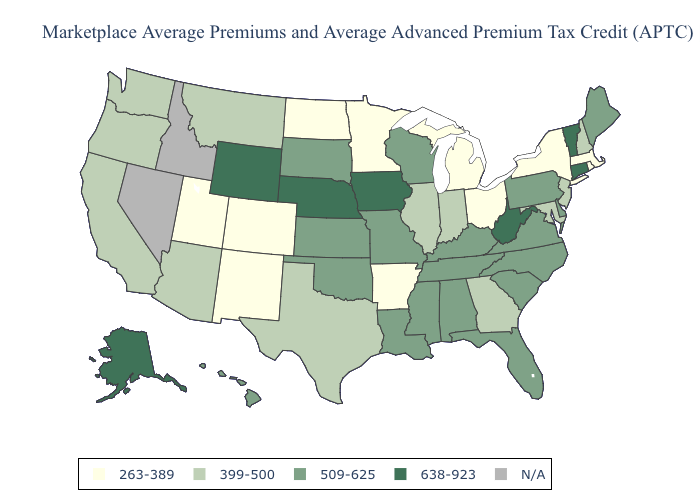What is the value of Nevada?
Concise answer only. N/A. Which states have the highest value in the USA?
Short answer required. Alaska, Connecticut, Iowa, Nebraska, Vermont, West Virginia, Wyoming. Name the states that have a value in the range 509-625?
Keep it brief. Alabama, Delaware, Florida, Hawaii, Kansas, Kentucky, Louisiana, Maine, Mississippi, Missouri, North Carolina, Oklahoma, Pennsylvania, South Carolina, South Dakota, Tennessee, Virginia, Wisconsin. What is the highest value in states that border Delaware?
Be succinct. 509-625. Does Virginia have the highest value in the USA?
Write a very short answer. No. Does the map have missing data?
Be succinct. Yes. Does Utah have the highest value in the USA?
Write a very short answer. No. Is the legend a continuous bar?
Quick response, please. No. What is the lowest value in the South?
Short answer required. 263-389. Which states have the lowest value in the Northeast?
Concise answer only. Massachusetts, New York, Rhode Island. What is the value of Ohio?
Write a very short answer. 263-389. Name the states that have a value in the range 638-923?
Keep it brief. Alaska, Connecticut, Iowa, Nebraska, Vermont, West Virginia, Wyoming. What is the highest value in the USA?
Short answer required. 638-923. Does Ohio have the lowest value in the MidWest?
Quick response, please. Yes. 